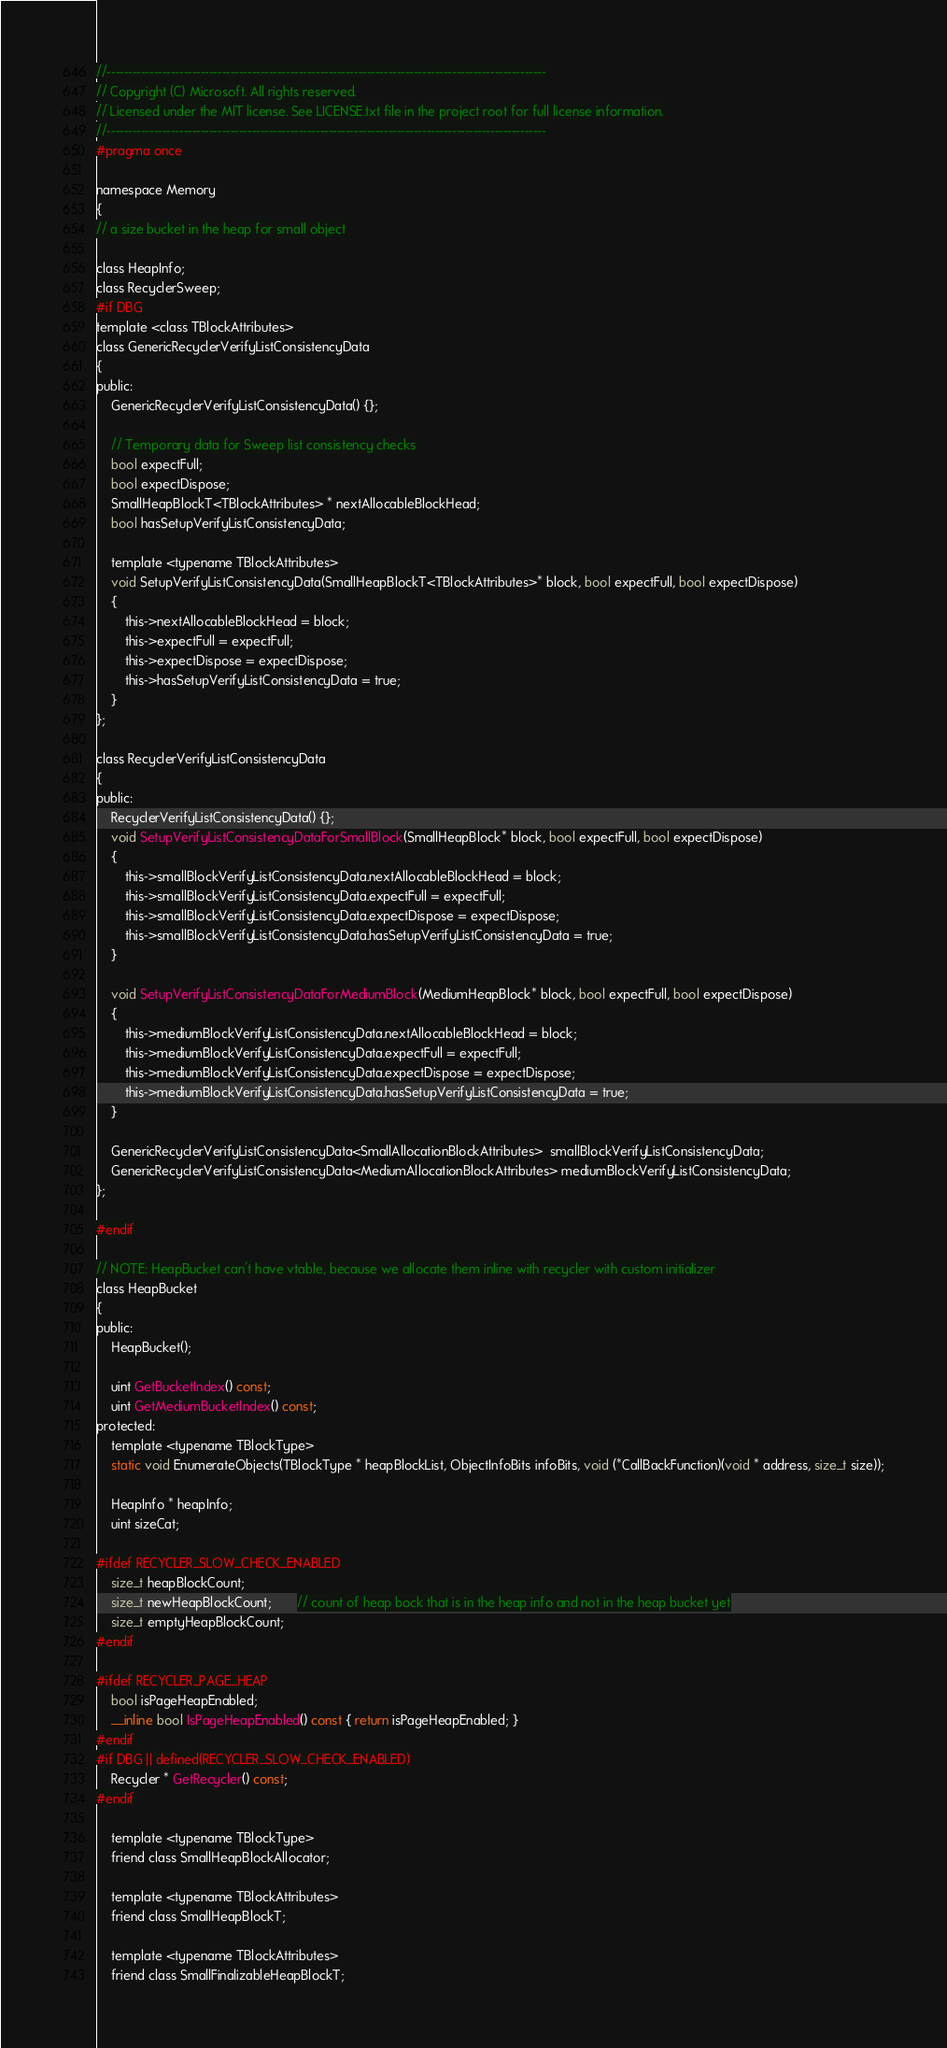<code> <loc_0><loc_0><loc_500><loc_500><_C_>//-------------------------------------------------------------------------------------------------------
// Copyright (C) Microsoft. All rights reserved.
// Licensed under the MIT license. See LICENSE.txt file in the project root for full license information.
//-------------------------------------------------------------------------------------------------------
#pragma once

namespace Memory
{
// a size bucket in the heap for small object

class HeapInfo;
class RecyclerSweep;
#if DBG
template <class TBlockAttributes>
class GenericRecyclerVerifyListConsistencyData
{
public:
    GenericRecyclerVerifyListConsistencyData() {};

    // Temporary data for Sweep list consistency checks
    bool expectFull;
    bool expectDispose;
    SmallHeapBlockT<TBlockAttributes> * nextAllocableBlockHead;
    bool hasSetupVerifyListConsistencyData;

    template <typename TBlockAttributes>
    void SetupVerifyListConsistencyData(SmallHeapBlockT<TBlockAttributes>* block, bool expectFull, bool expectDispose)
    {
        this->nextAllocableBlockHead = block;
        this->expectFull = expectFull;
        this->expectDispose = expectDispose;
        this->hasSetupVerifyListConsistencyData = true;
    }
};

class RecyclerVerifyListConsistencyData
{
public:
    RecyclerVerifyListConsistencyData() {};
    void SetupVerifyListConsistencyDataForSmallBlock(SmallHeapBlock* block, bool expectFull, bool expectDispose)
    {
        this->smallBlockVerifyListConsistencyData.nextAllocableBlockHead = block;
        this->smallBlockVerifyListConsistencyData.expectFull = expectFull;
        this->smallBlockVerifyListConsistencyData.expectDispose = expectDispose;
        this->smallBlockVerifyListConsistencyData.hasSetupVerifyListConsistencyData = true;
    }

    void SetupVerifyListConsistencyDataForMediumBlock(MediumHeapBlock* block, bool expectFull, bool expectDispose)
    {
        this->mediumBlockVerifyListConsistencyData.nextAllocableBlockHead = block;
        this->mediumBlockVerifyListConsistencyData.expectFull = expectFull;
        this->mediumBlockVerifyListConsistencyData.expectDispose = expectDispose;
        this->mediumBlockVerifyListConsistencyData.hasSetupVerifyListConsistencyData = true;
    }

    GenericRecyclerVerifyListConsistencyData<SmallAllocationBlockAttributes>  smallBlockVerifyListConsistencyData;
    GenericRecyclerVerifyListConsistencyData<MediumAllocationBlockAttributes> mediumBlockVerifyListConsistencyData;
};

#endif

// NOTE: HeapBucket can't have vtable, because we allocate them inline with recycler with custom initializer
class HeapBucket
{
public:
    HeapBucket();

    uint GetBucketIndex() const;
    uint GetMediumBucketIndex() const;
protected:
    template <typename TBlockType>
    static void EnumerateObjects(TBlockType * heapBlockList, ObjectInfoBits infoBits, void (*CallBackFunction)(void * address, size_t size));

    HeapInfo * heapInfo;
    uint sizeCat;

#ifdef RECYCLER_SLOW_CHECK_ENABLED
    size_t heapBlockCount;
    size_t newHeapBlockCount;       // count of heap bock that is in the heap info and not in the heap bucket yet
    size_t emptyHeapBlockCount;
#endif

#ifdef RECYCLER_PAGE_HEAP
    bool isPageHeapEnabled;
    __inline bool IsPageHeapEnabled() const { return isPageHeapEnabled; }
#endif
#if DBG || defined(RECYCLER_SLOW_CHECK_ENABLED)
    Recycler * GetRecycler() const;
#endif

    template <typename TBlockType>
    friend class SmallHeapBlockAllocator;

    template <typename TBlockAttributes>
    friend class SmallHeapBlockT;

    template <typename TBlockAttributes>
    friend class SmallFinalizableHeapBlockT;
</code> 